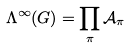<formula> <loc_0><loc_0><loc_500><loc_500>\Lambda ^ { \infty } ( G ) = \prod _ { \pi } \mathcal { A } _ { \pi }</formula> 